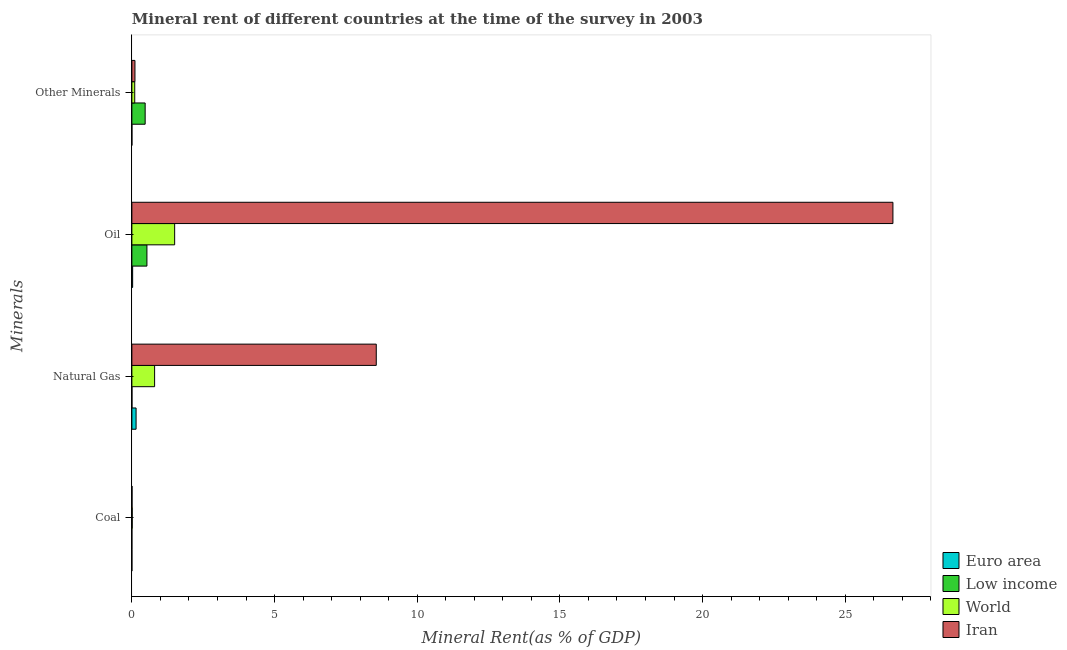How many groups of bars are there?
Offer a very short reply. 4. Are the number of bars per tick equal to the number of legend labels?
Keep it short and to the point. Yes. Are the number of bars on each tick of the Y-axis equal?
Make the answer very short. Yes. How many bars are there on the 1st tick from the bottom?
Ensure brevity in your answer.  4. What is the label of the 4th group of bars from the top?
Keep it short and to the point. Coal. What is the  rent of other minerals in Low income?
Your response must be concise. 0.47. Across all countries, what is the maximum  rent of other minerals?
Give a very brief answer. 0.47. Across all countries, what is the minimum  rent of other minerals?
Provide a short and direct response. 0. What is the total natural gas rent in the graph?
Ensure brevity in your answer.  9.51. What is the difference between the oil rent in Low income and that in World?
Ensure brevity in your answer.  -0.97. What is the difference between the oil rent in Iran and the natural gas rent in World?
Provide a succinct answer. 25.87. What is the average oil rent per country?
Your answer should be very brief. 7.18. What is the difference between the coal rent and natural gas rent in Iran?
Offer a very short reply. -8.56. In how many countries, is the natural gas rent greater than 14 %?
Keep it short and to the point. 0. What is the ratio of the coal rent in Euro area to that in Iran?
Ensure brevity in your answer.  0.06. Is the difference between the coal rent in Iran and Euro area greater than the difference between the natural gas rent in Iran and Euro area?
Your response must be concise. No. What is the difference between the highest and the second highest  rent of other minerals?
Ensure brevity in your answer.  0.36. What is the difference between the highest and the lowest coal rent?
Provide a short and direct response. 0.01. In how many countries, is the coal rent greater than the average coal rent taken over all countries?
Provide a short and direct response. 2. Is the sum of the natural gas rent in Iran and Euro area greater than the maximum  rent of other minerals across all countries?
Offer a terse response. Yes. Is it the case that in every country, the sum of the natural gas rent and  rent of other minerals is greater than the sum of oil rent and coal rent?
Your answer should be very brief. No. What does the 4th bar from the top in Coal represents?
Offer a very short reply. Euro area. What does the 4th bar from the bottom in Natural Gas represents?
Offer a very short reply. Iran. Are all the bars in the graph horizontal?
Your response must be concise. Yes. Are the values on the major ticks of X-axis written in scientific E-notation?
Offer a terse response. No. Does the graph contain any zero values?
Provide a short and direct response. No. Does the graph contain grids?
Ensure brevity in your answer.  No. How are the legend labels stacked?
Your answer should be compact. Vertical. What is the title of the graph?
Your response must be concise. Mineral rent of different countries at the time of the survey in 2003. What is the label or title of the X-axis?
Keep it short and to the point. Mineral Rent(as % of GDP). What is the label or title of the Y-axis?
Offer a very short reply. Minerals. What is the Mineral Rent(as % of GDP) of Euro area in Coal?
Offer a terse response. 0. What is the Mineral Rent(as % of GDP) in Low income in Coal?
Ensure brevity in your answer.  0. What is the Mineral Rent(as % of GDP) of World in Coal?
Keep it short and to the point. 0.01. What is the Mineral Rent(as % of GDP) of Iran in Coal?
Your answer should be compact. 0.01. What is the Mineral Rent(as % of GDP) in Euro area in Natural Gas?
Offer a very short reply. 0.15. What is the Mineral Rent(as % of GDP) of Low income in Natural Gas?
Your answer should be compact. 0. What is the Mineral Rent(as % of GDP) in World in Natural Gas?
Ensure brevity in your answer.  0.8. What is the Mineral Rent(as % of GDP) of Iran in Natural Gas?
Give a very brief answer. 8.56. What is the Mineral Rent(as % of GDP) in Euro area in Oil?
Offer a very short reply. 0.03. What is the Mineral Rent(as % of GDP) of Low income in Oil?
Ensure brevity in your answer.  0.53. What is the Mineral Rent(as % of GDP) in World in Oil?
Your response must be concise. 1.5. What is the Mineral Rent(as % of GDP) in Iran in Oil?
Your response must be concise. 26.67. What is the Mineral Rent(as % of GDP) in Euro area in Other Minerals?
Offer a very short reply. 0. What is the Mineral Rent(as % of GDP) in Low income in Other Minerals?
Your response must be concise. 0.47. What is the Mineral Rent(as % of GDP) of World in Other Minerals?
Your answer should be very brief. 0.1. What is the Mineral Rent(as % of GDP) in Iran in Other Minerals?
Provide a short and direct response. 0.11. Across all Minerals, what is the maximum Mineral Rent(as % of GDP) in Euro area?
Offer a very short reply. 0.15. Across all Minerals, what is the maximum Mineral Rent(as % of GDP) of Low income?
Your response must be concise. 0.53. Across all Minerals, what is the maximum Mineral Rent(as % of GDP) of World?
Make the answer very short. 1.5. Across all Minerals, what is the maximum Mineral Rent(as % of GDP) in Iran?
Offer a very short reply. 26.67. Across all Minerals, what is the minimum Mineral Rent(as % of GDP) in Euro area?
Give a very brief answer. 0. Across all Minerals, what is the minimum Mineral Rent(as % of GDP) of Low income?
Your response must be concise. 0. Across all Minerals, what is the minimum Mineral Rent(as % of GDP) of World?
Give a very brief answer. 0.01. Across all Minerals, what is the minimum Mineral Rent(as % of GDP) of Iran?
Offer a terse response. 0.01. What is the total Mineral Rent(as % of GDP) of Euro area in the graph?
Keep it short and to the point. 0.18. What is the total Mineral Rent(as % of GDP) in World in the graph?
Your answer should be very brief. 2.41. What is the total Mineral Rent(as % of GDP) of Iran in the graph?
Your response must be concise. 35.35. What is the difference between the Mineral Rent(as % of GDP) in Euro area in Coal and that in Natural Gas?
Give a very brief answer. -0.15. What is the difference between the Mineral Rent(as % of GDP) of Low income in Coal and that in Natural Gas?
Keep it short and to the point. -0. What is the difference between the Mineral Rent(as % of GDP) of World in Coal and that in Natural Gas?
Keep it short and to the point. -0.78. What is the difference between the Mineral Rent(as % of GDP) of Iran in Coal and that in Natural Gas?
Keep it short and to the point. -8.56. What is the difference between the Mineral Rent(as % of GDP) in Euro area in Coal and that in Oil?
Provide a short and direct response. -0.03. What is the difference between the Mineral Rent(as % of GDP) of Low income in Coal and that in Oil?
Offer a very short reply. -0.53. What is the difference between the Mineral Rent(as % of GDP) in World in Coal and that in Oil?
Your answer should be compact. -1.49. What is the difference between the Mineral Rent(as % of GDP) in Iran in Coal and that in Oil?
Provide a short and direct response. -26.66. What is the difference between the Mineral Rent(as % of GDP) of Euro area in Coal and that in Other Minerals?
Your answer should be very brief. -0. What is the difference between the Mineral Rent(as % of GDP) in Low income in Coal and that in Other Minerals?
Provide a short and direct response. -0.47. What is the difference between the Mineral Rent(as % of GDP) in World in Coal and that in Other Minerals?
Your response must be concise. -0.09. What is the difference between the Mineral Rent(as % of GDP) of Iran in Coal and that in Other Minerals?
Your response must be concise. -0.1. What is the difference between the Mineral Rent(as % of GDP) in Euro area in Natural Gas and that in Oil?
Offer a very short reply. 0.12. What is the difference between the Mineral Rent(as % of GDP) of Low income in Natural Gas and that in Oil?
Keep it short and to the point. -0.52. What is the difference between the Mineral Rent(as % of GDP) in World in Natural Gas and that in Oil?
Your answer should be very brief. -0.7. What is the difference between the Mineral Rent(as % of GDP) in Iran in Natural Gas and that in Oil?
Offer a terse response. -18.11. What is the difference between the Mineral Rent(as % of GDP) of Euro area in Natural Gas and that in Other Minerals?
Ensure brevity in your answer.  0.15. What is the difference between the Mineral Rent(as % of GDP) of Low income in Natural Gas and that in Other Minerals?
Your answer should be compact. -0.46. What is the difference between the Mineral Rent(as % of GDP) of World in Natural Gas and that in Other Minerals?
Keep it short and to the point. 0.7. What is the difference between the Mineral Rent(as % of GDP) in Iran in Natural Gas and that in Other Minerals?
Offer a very short reply. 8.46. What is the difference between the Mineral Rent(as % of GDP) of Euro area in Oil and that in Other Minerals?
Provide a short and direct response. 0.03. What is the difference between the Mineral Rent(as % of GDP) in Low income in Oil and that in Other Minerals?
Offer a terse response. 0.06. What is the difference between the Mineral Rent(as % of GDP) of World in Oil and that in Other Minerals?
Your answer should be compact. 1.4. What is the difference between the Mineral Rent(as % of GDP) of Iran in Oil and that in Other Minerals?
Make the answer very short. 26.56. What is the difference between the Mineral Rent(as % of GDP) of Euro area in Coal and the Mineral Rent(as % of GDP) of Low income in Natural Gas?
Offer a very short reply. -0. What is the difference between the Mineral Rent(as % of GDP) of Euro area in Coal and the Mineral Rent(as % of GDP) of World in Natural Gas?
Provide a succinct answer. -0.8. What is the difference between the Mineral Rent(as % of GDP) in Euro area in Coal and the Mineral Rent(as % of GDP) in Iran in Natural Gas?
Your answer should be very brief. -8.56. What is the difference between the Mineral Rent(as % of GDP) in Low income in Coal and the Mineral Rent(as % of GDP) in World in Natural Gas?
Give a very brief answer. -0.8. What is the difference between the Mineral Rent(as % of GDP) of Low income in Coal and the Mineral Rent(as % of GDP) of Iran in Natural Gas?
Offer a terse response. -8.56. What is the difference between the Mineral Rent(as % of GDP) of World in Coal and the Mineral Rent(as % of GDP) of Iran in Natural Gas?
Your response must be concise. -8.55. What is the difference between the Mineral Rent(as % of GDP) in Euro area in Coal and the Mineral Rent(as % of GDP) in Low income in Oil?
Your answer should be very brief. -0.53. What is the difference between the Mineral Rent(as % of GDP) of Euro area in Coal and the Mineral Rent(as % of GDP) of World in Oil?
Offer a terse response. -1.5. What is the difference between the Mineral Rent(as % of GDP) of Euro area in Coal and the Mineral Rent(as % of GDP) of Iran in Oil?
Give a very brief answer. -26.67. What is the difference between the Mineral Rent(as % of GDP) in Low income in Coal and the Mineral Rent(as % of GDP) in World in Oil?
Ensure brevity in your answer.  -1.5. What is the difference between the Mineral Rent(as % of GDP) in Low income in Coal and the Mineral Rent(as % of GDP) in Iran in Oil?
Provide a succinct answer. -26.67. What is the difference between the Mineral Rent(as % of GDP) in World in Coal and the Mineral Rent(as % of GDP) in Iran in Oil?
Your response must be concise. -26.66. What is the difference between the Mineral Rent(as % of GDP) in Euro area in Coal and the Mineral Rent(as % of GDP) in Low income in Other Minerals?
Keep it short and to the point. -0.47. What is the difference between the Mineral Rent(as % of GDP) of Euro area in Coal and the Mineral Rent(as % of GDP) of World in Other Minerals?
Offer a very short reply. -0.1. What is the difference between the Mineral Rent(as % of GDP) in Euro area in Coal and the Mineral Rent(as % of GDP) in Iran in Other Minerals?
Offer a terse response. -0.11. What is the difference between the Mineral Rent(as % of GDP) in Low income in Coal and the Mineral Rent(as % of GDP) in World in Other Minerals?
Provide a short and direct response. -0.1. What is the difference between the Mineral Rent(as % of GDP) in Low income in Coal and the Mineral Rent(as % of GDP) in Iran in Other Minerals?
Offer a very short reply. -0.11. What is the difference between the Mineral Rent(as % of GDP) in World in Coal and the Mineral Rent(as % of GDP) in Iran in Other Minerals?
Offer a very short reply. -0.1. What is the difference between the Mineral Rent(as % of GDP) in Euro area in Natural Gas and the Mineral Rent(as % of GDP) in Low income in Oil?
Ensure brevity in your answer.  -0.38. What is the difference between the Mineral Rent(as % of GDP) of Euro area in Natural Gas and the Mineral Rent(as % of GDP) of World in Oil?
Ensure brevity in your answer.  -1.35. What is the difference between the Mineral Rent(as % of GDP) in Euro area in Natural Gas and the Mineral Rent(as % of GDP) in Iran in Oil?
Your answer should be compact. -26.52. What is the difference between the Mineral Rent(as % of GDP) in Low income in Natural Gas and the Mineral Rent(as % of GDP) in World in Oil?
Ensure brevity in your answer.  -1.5. What is the difference between the Mineral Rent(as % of GDP) of Low income in Natural Gas and the Mineral Rent(as % of GDP) of Iran in Oil?
Make the answer very short. -26.67. What is the difference between the Mineral Rent(as % of GDP) in World in Natural Gas and the Mineral Rent(as % of GDP) in Iran in Oil?
Offer a terse response. -25.87. What is the difference between the Mineral Rent(as % of GDP) of Euro area in Natural Gas and the Mineral Rent(as % of GDP) of Low income in Other Minerals?
Provide a short and direct response. -0.32. What is the difference between the Mineral Rent(as % of GDP) in Euro area in Natural Gas and the Mineral Rent(as % of GDP) in World in Other Minerals?
Your answer should be compact. 0.05. What is the difference between the Mineral Rent(as % of GDP) of Euro area in Natural Gas and the Mineral Rent(as % of GDP) of Iran in Other Minerals?
Offer a very short reply. 0.04. What is the difference between the Mineral Rent(as % of GDP) in Low income in Natural Gas and the Mineral Rent(as % of GDP) in World in Other Minerals?
Make the answer very short. -0.1. What is the difference between the Mineral Rent(as % of GDP) in Low income in Natural Gas and the Mineral Rent(as % of GDP) in Iran in Other Minerals?
Offer a terse response. -0.1. What is the difference between the Mineral Rent(as % of GDP) in World in Natural Gas and the Mineral Rent(as % of GDP) in Iran in Other Minerals?
Keep it short and to the point. 0.69. What is the difference between the Mineral Rent(as % of GDP) in Euro area in Oil and the Mineral Rent(as % of GDP) in Low income in Other Minerals?
Offer a terse response. -0.44. What is the difference between the Mineral Rent(as % of GDP) in Euro area in Oil and the Mineral Rent(as % of GDP) in World in Other Minerals?
Offer a very short reply. -0.07. What is the difference between the Mineral Rent(as % of GDP) of Euro area in Oil and the Mineral Rent(as % of GDP) of Iran in Other Minerals?
Your answer should be very brief. -0.08. What is the difference between the Mineral Rent(as % of GDP) of Low income in Oil and the Mineral Rent(as % of GDP) of World in Other Minerals?
Make the answer very short. 0.43. What is the difference between the Mineral Rent(as % of GDP) of Low income in Oil and the Mineral Rent(as % of GDP) of Iran in Other Minerals?
Offer a very short reply. 0.42. What is the difference between the Mineral Rent(as % of GDP) of World in Oil and the Mineral Rent(as % of GDP) of Iran in Other Minerals?
Your response must be concise. 1.39. What is the average Mineral Rent(as % of GDP) of Euro area per Minerals?
Make the answer very short. 0.04. What is the average Mineral Rent(as % of GDP) of Low income per Minerals?
Offer a very short reply. 0.25. What is the average Mineral Rent(as % of GDP) in World per Minerals?
Keep it short and to the point. 0.6. What is the average Mineral Rent(as % of GDP) of Iran per Minerals?
Offer a very short reply. 8.84. What is the difference between the Mineral Rent(as % of GDP) of Euro area and Mineral Rent(as % of GDP) of World in Coal?
Your answer should be very brief. -0.01. What is the difference between the Mineral Rent(as % of GDP) of Euro area and Mineral Rent(as % of GDP) of Iran in Coal?
Your answer should be compact. -0.01. What is the difference between the Mineral Rent(as % of GDP) of Low income and Mineral Rent(as % of GDP) of World in Coal?
Provide a succinct answer. -0.01. What is the difference between the Mineral Rent(as % of GDP) of Low income and Mineral Rent(as % of GDP) of Iran in Coal?
Your response must be concise. -0.01. What is the difference between the Mineral Rent(as % of GDP) in World and Mineral Rent(as % of GDP) in Iran in Coal?
Your answer should be very brief. 0.01. What is the difference between the Mineral Rent(as % of GDP) in Euro area and Mineral Rent(as % of GDP) in Low income in Natural Gas?
Provide a succinct answer. 0.14. What is the difference between the Mineral Rent(as % of GDP) of Euro area and Mineral Rent(as % of GDP) of World in Natural Gas?
Your answer should be compact. -0.65. What is the difference between the Mineral Rent(as % of GDP) of Euro area and Mineral Rent(as % of GDP) of Iran in Natural Gas?
Provide a short and direct response. -8.42. What is the difference between the Mineral Rent(as % of GDP) in Low income and Mineral Rent(as % of GDP) in World in Natural Gas?
Provide a succinct answer. -0.79. What is the difference between the Mineral Rent(as % of GDP) of Low income and Mineral Rent(as % of GDP) of Iran in Natural Gas?
Your answer should be very brief. -8.56. What is the difference between the Mineral Rent(as % of GDP) in World and Mineral Rent(as % of GDP) in Iran in Natural Gas?
Ensure brevity in your answer.  -7.77. What is the difference between the Mineral Rent(as % of GDP) of Euro area and Mineral Rent(as % of GDP) of Low income in Oil?
Give a very brief answer. -0.5. What is the difference between the Mineral Rent(as % of GDP) of Euro area and Mineral Rent(as % of GDP) of World in Oil?
Ensure brevity in your answer.  -1.47. What is the difference between the Mineral Rent(as % of GDP) in Euro area and Mineral Rent(as % of GDP) in Iran in Oil?
Offer a very short reply. -26.64. What is the difference between the Mineral Rent(as % of GDP) of Low income and Mineral Rent(as % of GDP) of World in Oil?
Keep it short and to the point. -0.97. What is the difference between the Mineral Rent(as % of GDP) of Low income and Mineral Rent(as % of GDP) of Iran in Oil?
Give a very brief answer. -26.14. What is the difference between the Mineral Rent(as % of GDP) in World and Mineral Rent(as % of GDP) in Iran in Oil?
Offer a terse response. -25.17. What is the difference between the Mineral Rent(as % of GDP) of Euro area and Mineral Rent(as % of GDP) of Low income in Other Minerals?
Ensure brevity in your answer.  -0.46. What is the difference between the Mineral Rent(as % of GDP) of Euro area and Mineral Rent(as % of GDP) of World in Other Minerals?
Keep it short and to the point. -0.1. What is the difference between the Mineral Rent(as % of GDP) of Euro area and Mineral Rent(as % of GDP) of Iran in Other Minerals?
Offer a very short reply. -0.11. What is the difference between the Mineral Rent(as % of GDP) in Low income and Mineral Rent(as % of GDP) in World in Other Minerals?
Provide a succinct answer. 0.36. What is the difference between the Mineral Rent(as % of GDP) of Low income and Mineral Rent(as % of GDP) of Iran in Other Minerals?
Your answer should be very brief. 0.36. What is the difference between the Mineral Rent(as % of GDP) of World and Mineral Rent(as % of GDP) of Iran in Other Minerals?
Make the answer very short. -0.01. What is the ratio of the Mineral Rent(as % of GDP) in Euro area in Coal to that in Natural Gas?
Provide a succinct answer. 0. What is the ratio of the Mineral Rent(as % of GDP) in Low income in Coal to that in Natural Gas?
Offer a very short reply. 0.09. What is the ratio of the Mineral Rent(as % of GDP) of World in Coal to that in Natural Gas?
Your answer should be compact. 0.02. What is the ratio of the Mineral Rent(as % of GDP) in Iran in Coal to that in Natural Gas?
Offer a terse response. 0. What is the ratio of the Mineral Rent(as % of GDP) of Euro area in Coal to that in Oil?
Provide a succinct answer. 0.01. What is the ratio of the Mineral Rent(as % of GDP) of Low income in Coal to that in Oil?
Ensure brevity in your answer.  0. What is the ratio of the Mineral Rent(as % of GDP) of World in Coal to that in Oil?
Make the answer very short. 0.01. What is the ratio of the Mineral Rent(as % of GDP) in Iran in Coal to that in Oil?
Offer a very short reply. 0. What is the ratio of the Mineral Rent(as % of GDP) in Euro area in Coal to that in Other Minerals?
Provide a succinct answer. 0.39. What is the ratio of the Mineral Rent(as % of GDP) of Low income in Coal to that in Other Minerals?
Provide a succinct answer. 0. What is the ratio of the Mineral Rent(as % of GDP) in World in Coal to that in Other Minerals?
Make the answer very short. 0.12. What is the ratio of the Mineral Rent(as % of GDP) of Iran in Coal to that in Other Minerals?
Make the answer very short. 0.05. What is the ratio of the Mineral Rent(as % of GDP) in Euro area in Natural Gas to that in Oil?
Offer a very short reply. 5.5. What is the ratio of the Mineral Rent(as % of GDP) of Low income in Natural Gas to that in Oil?
Your response must be concise. 0.01. What is the ratio of the Mineral Rent(as % of GDP) in World in Natural Gas to that in Oil?
Give a very brief answer. 0.53. What is the ratio of the Mineral Rent(as % of GDP) in Iran in Natural Gas to that in Oil?
Your answer should be very brief. 0.32. What is the ratio of the Mineral Rent(as % of GDP) in Euro area in Natural Gas to that in Other Minerals?
Provide a short and direct response. 160.82. What is the ratio of the Mineral Rent(as % of GDP) in Low income in Natural Gas to that in Other Minerals?
Make the answer very short. 0.01. What is the ratio of the Mineral Rent(as % of GDP) of World in Natural Gas to that in Other Minerals?
Offer a terse response. 7.93. What is the ratio of the Mineral Rent(as % of GDP) in Iran in Natural Gas to that in Other Minerals?
Make the answer very short. 79.36. What is the ratio of the Mineral Rent(as % of GDP) of Euro area in Oil to that in Other Minerals?
Ensure brevity in your answer.  29.25. What is the ratio of the Mineral Rent(as % of GDP) of Low income in Oil to that in Other Minerals?
Make the answer very short. 1.13. What is the ratio of the Mineral Rent(as % of GDP) in World in Oil to that in Other Minerals?
Keep it short and to the point. 14.92. What is the ratio of the Mineral Rent(as % of GDP) of Iran in Oil to that in Other Minerals?
Provide a short and direct response. 247.11. What is the difference between the highest and the second highest Mineral Rent(as % of GDP) of Euro area?
Ensure brevity in your answer.  0.12. What is the difference between the highest and the second highest Mineral Rent(as % of GDP) of Low income?
Provide a short and direct response. 0.06. What is the difference between the highest and the second highest Mineral Rent(as % of GDP) of World?
Offer a terse response. 0.7. What is the difference between the highest and the second highest Mineral Rent(as % of GDP) of Iran?
Your answer should be very brief. 18.11. What is the difference between the highest and the lowest Mineral Rent(as % of GDP) in Euro area?
Keep it short and to the point. 0.15. What is the difference between the highest and the lowest Mineral Rent(as % of GDP) of Low income?
Make the answer very short. 0.53. What is the difference between the highest and the lowest Mineral Rent(as % of GDP) of World?
Offer a terse response. 1.49. What is the difference between the highest and the lowest Mineral Rent(as % of GDP) in Iran?
Offer a very short reply. 26.66. 